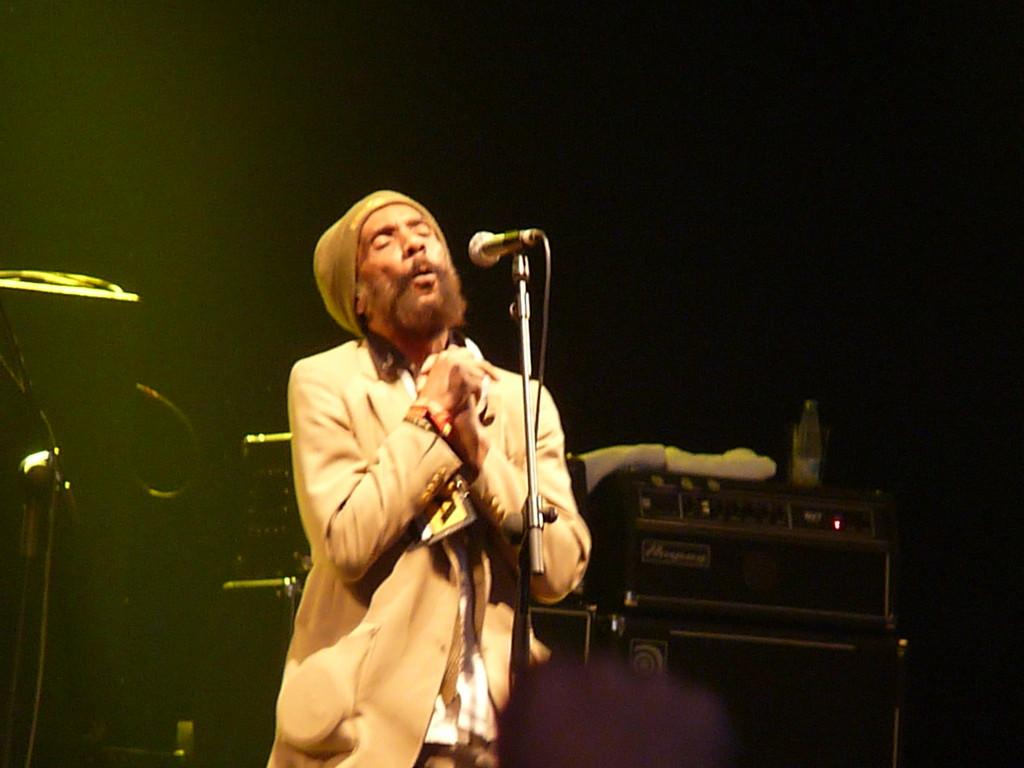What is the person in the image doing? The person is singing. What is the person using to sing? The person is in front of a microphone with a stand and wire. What can be seen in the background of the image? There are boxes, cloth, a bottle, a rod, and wires in the background of the image. How is the background view in the image? The background view is dark. How does the person pull the yam out of the snow in the image? There is no yam or snow present in the image; it features a person singing in front of a microphone with a stand and wire. 